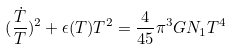<formula> <loc_0><loc_0><loc_500><loc_500>( \frac { \dot { T } } { T } ) ^ { 2 } + \epsilon ( T ) T ^ { 2 } = \frac { 4 } { 4 5 } \pi ^ { 3 } G N _ { 1 } T ^ { 4 }</formula> 